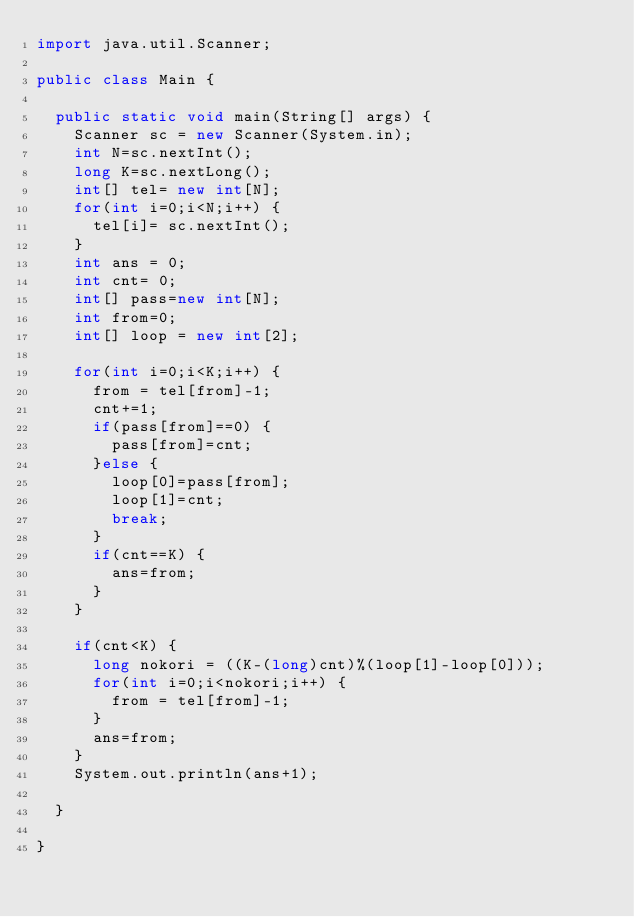<code> <loc_0><loc_0><loc_500><loc_500><_Java_>import java.util.Scanner;

public class Main {

	public static void main(String[] args) {
		Scanner sc = new Scanner(System.in);
		int N=sc.nextInt();
		long K=sc.nextLong();
		int[] tel= new int[N];
		for(int i=0;i<N;i++) {
			tel[i]= sc.nextInt();
		}
		int ans = 0;
		int cnt= 0;
		int[] pass=new int[N];
		int from=0;
		int[] loop = new int[2];
		
		for(int i=0;i<K;i++) {
			from = tel[from]-1;
			cnt+=1;
			if(pass[from]==0) {
				pass[from]=cnt;
			}else {
				loop[0]=pass[from];
				loop[1]=cnt;
				break;
			}
			if(cnt==K) {
				ans=from;
			}
		}
		
		if(cnt<K) {
			long nokori = ((K-(long)cnt)%(loop[1]-loop[0]));
			for(int i=0;i<nokori;i++) {
				from = tel[from]-1;
			}
			ans=from;
		}
		System.out.println(ans+1);
		
	}

}</code> 